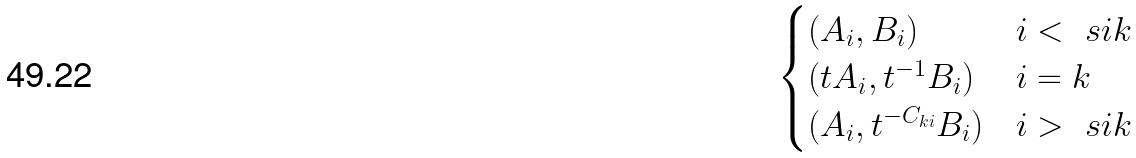<formula> <loc_0><loc_0><loc_500><loc_500>\begin{cases} ( A _ { i } , B _ { i } ) & i < _ { \ } s i k \\ ( t A _ { i } , t ^ { - 1 } B _ { i } ) & i = k \\ ( A _ { i } , t ^ { - C _ { k i } } B _ { i } ) & i > _ { \ } s i k \end{cases}</formula> 